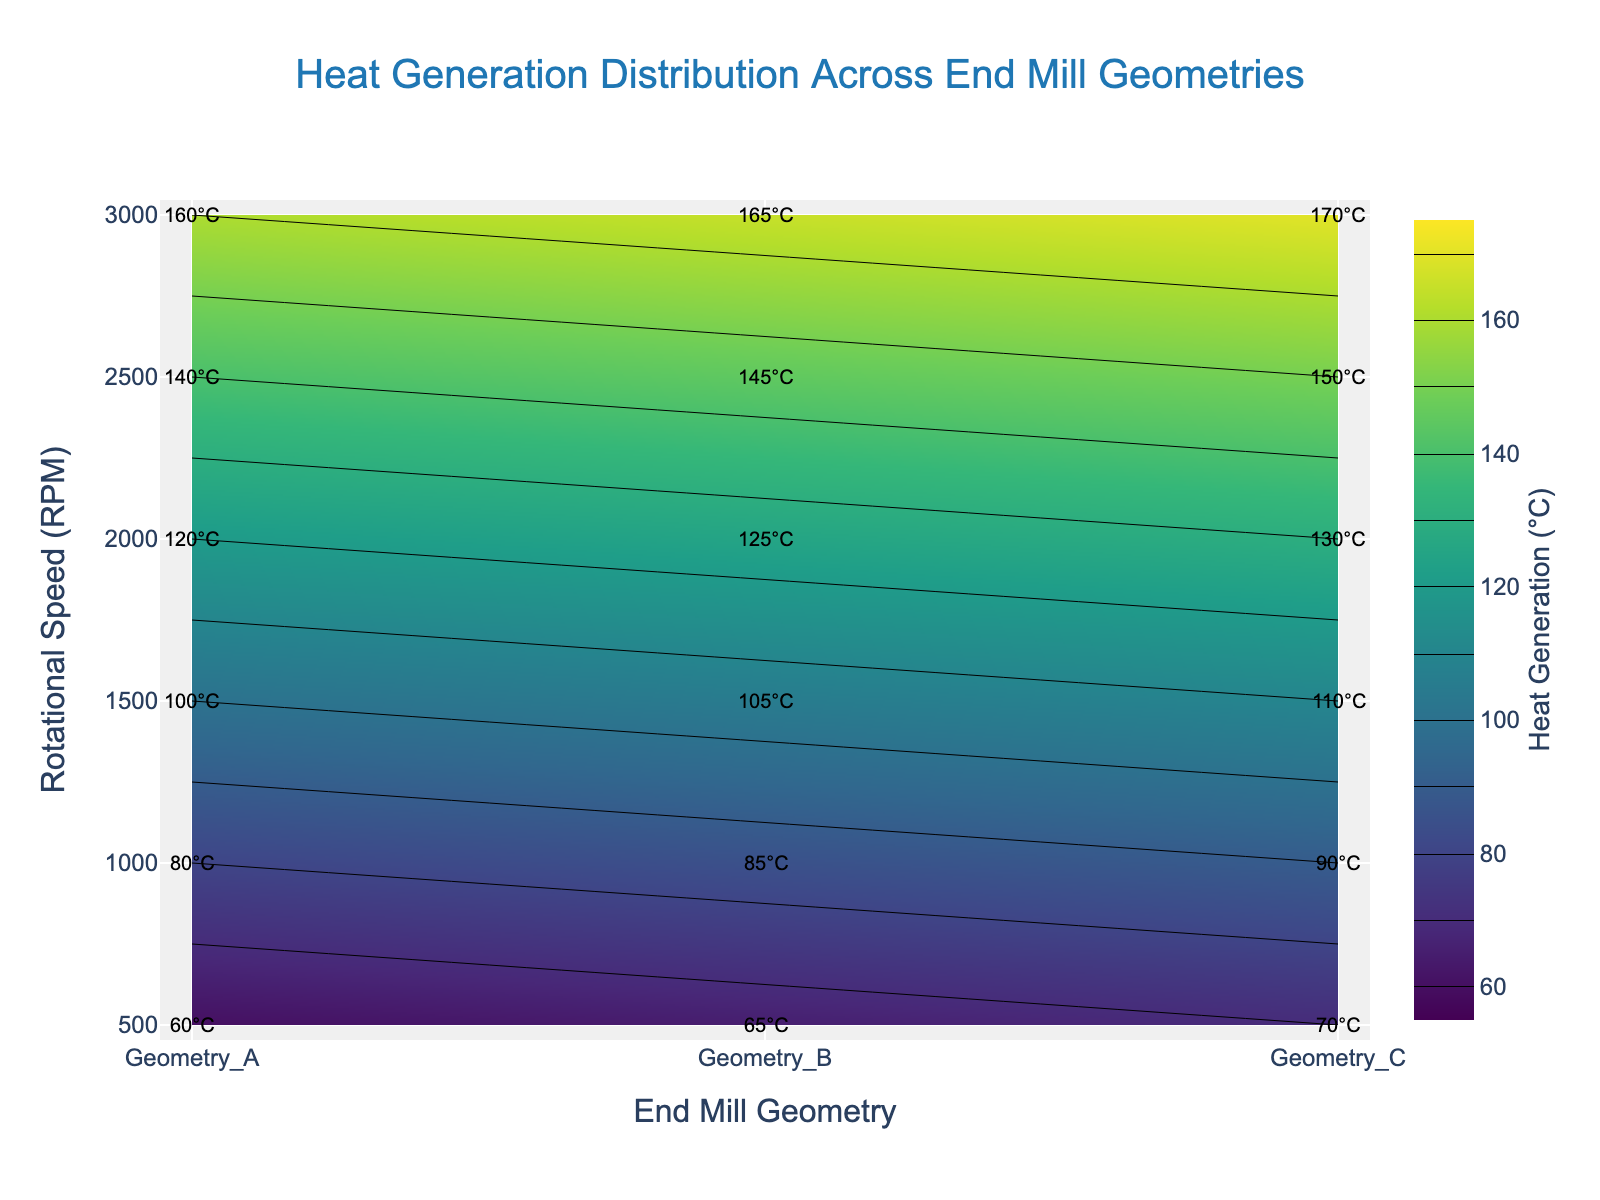What is the title of the plot? The title of the plot is located at the top center of the figure. The text reads "Heat Generation Distribution Across End Mill Geometries".
Answer: Heat Generation Distribution Across End Mill Geometries What does the colorbar represent on the contour plot? The colorbar represents the heat generation values in degrees Celsius (°C). It is labeled with "Heat Generation (°C)" on the right side of the plot.
Answer: Heat Generation (°C) At what rotational speed does Geometry C produce a heat generation of 130°C? By looking at the contour plot, locate the label "130°C" along the y-axis (rotational speed) next to Geometry C. The corresponding rotational speed is shown at the 2000 RPM mark.
Answer: 2000 RPM How does the heat generation for Geometry B change from 500 RPM to 3000 RPM? Find Geometry B along the x-axis, and observe the heat generation values at different points along the y-axis from 500 RPM to 3000 RPM. The values increase from 65°C at 500 RPM to 165°C at 3000 RPM.
Answer: Increases from 65°C to 165°C Which end mill geometry has the highest heat generation at 2500 RPM? Identify the 2500 RPM mark on the y-axis and look across the x-axis to find the highest heat generation value. Geometry C has the highest heat generation at 150°C.
Answer: Geometry C What is the difference in heat generation between Geometry A and Geometry C at 1500 RPM? Locate the heat generation values for Geometry A and Geometry C at the 1500 RPM mark on the y-axis. Geometry A has 100°C, and Geometry C has 110°C. The difference is 110°C - 100°C = 10°C.
Answer: 10°C Which geometry produces the least heat at 3000 RPM? At the 3000 RPM mark on the y-axis, compare the heat generation values for all three geometries. Geometry A produces the least heat at 160°C.
Answer: Geometry A How many RPM levels are displayed in the plot? Count the unique RPM levels listed along the y-axis. The levels are 500, 1000, 1500, 2000, 2500, and 3000 RPM, accounting for six different levels.
Answer: Six What is the average heat generation across all geometries at 1000 RPM? Find the heat generation values for all geometries at the 1000 RPM mark: Geometry A (80°C), Geometry B (85°C), and Geometry C (90°C). The average is calculated as (80 + 85 + 90) / 3 = 85°C.
Answer: 85°C 